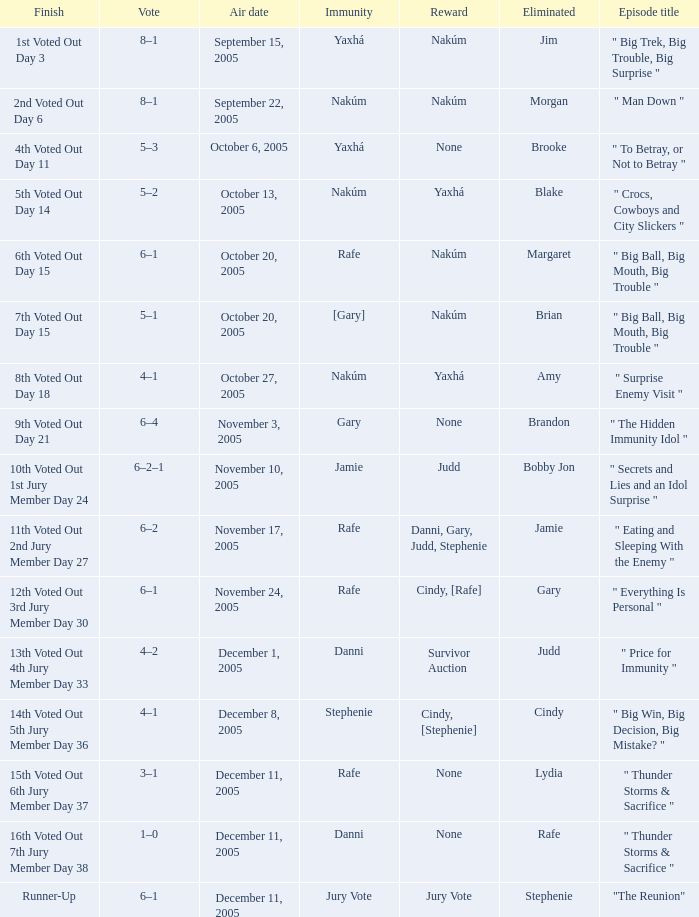How many air dates were there when Morgan was eliminated? 1.0. 